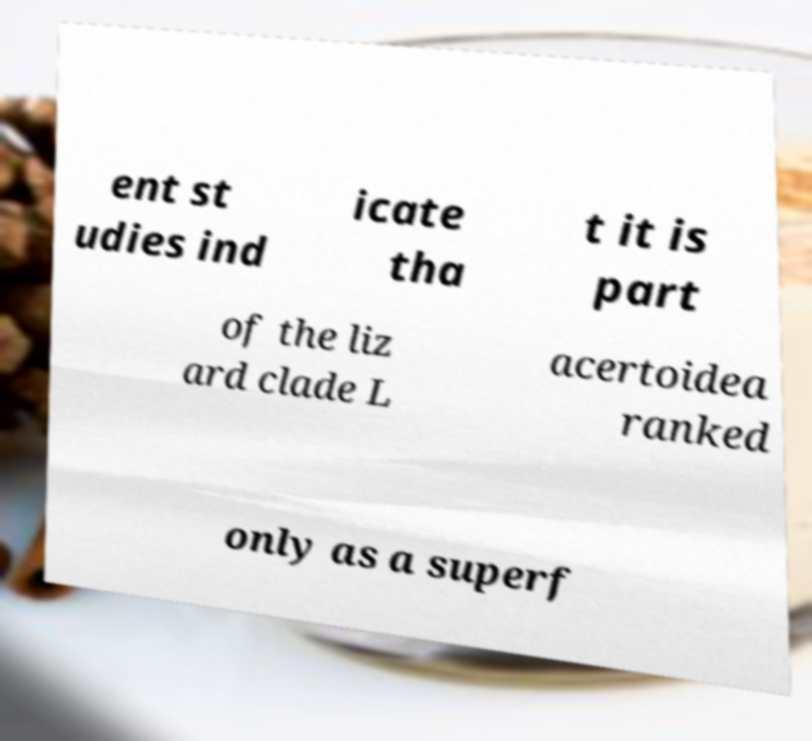I need the written content from this picture converted into text. Can you do that? ent st udies ind icate tha t it is part of the liz ard clade L acertoidea ranked only as a superf 